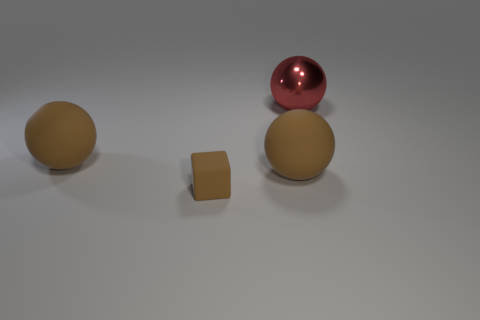What number of small things are either brown cylinders or red shiny objects?
Your answer should be compact. 0. Is the number of small gray shiny blocks less than the number of large red balls?
Provide a succinct answer. Yes. Is the size of the brown object on the right side of the tiny thing the same as the object to the left of the tiny brown block?
Offer a terse response. Yes. What number of red objects are either big things or tiny matte blocks?
Provide a short and direct response. 1. Is the number of large blue metal objects greater than the number of blocks?
Offer a terse response. No. Does the metallic thing have the same color as the cube?
Your answer should be compact. No. What number of things are either brown balls or big balls right of the small brown block?
Offer a terse response. 3. How many other objects are the same shape as the tiny brown object?
Keep it short and to the point. 0. Are there fewer small brown cubes in front of the cube than brown balls behind the red sphere?
Provide a short and direct response. No. Is there anything else that is made of the same material as the big red ball?
Provide a short and direct response. No. 